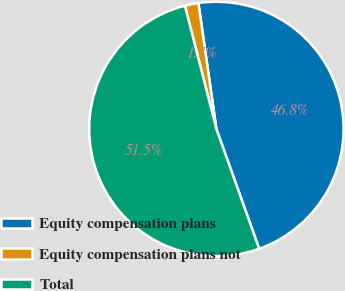Convert chart to OTSL. <chart><loc_0><loc_0><loc_500><loc_500><pie_chart><fcel>Equity compensation plans<fcel>Equity compensation plans not<fcel>Total<nl><fcel>46.8%<fcel>1.72%<fcel>51.48%<nl></chart> 